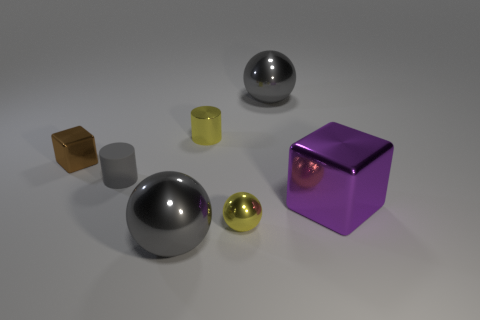What could the different textures of these objects tell us about their materials? The varied textures suggest a range of materials: the shiny surfaces imply metals like steel or chrome, while the matte finishes might indicate objects made from ceramics or plastics. 